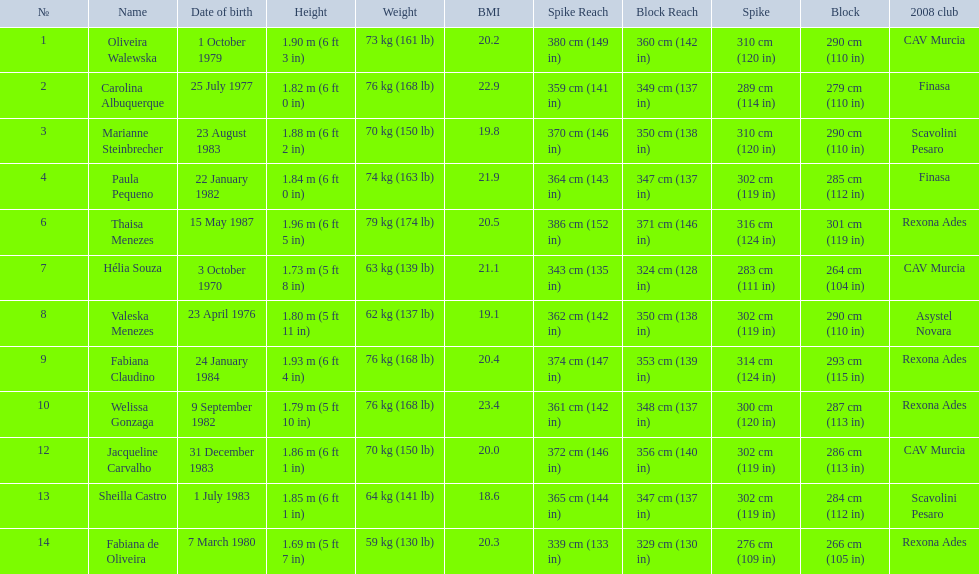What are all of the names? Oliveira Walewska, Carolina Albuquerque, Marianne Steinbrecher, Paula Pequeno, Thaisa Menezes, Hélia Souza, Valeska Menezes, Fabiana Claudino, Welissa Gonzaga, Jacqueline Carvalho, Sheilla Castro, Fabiana de Oliveira. What are their weights? 73 kg (161 lb), 76 kg (168 lb), 70 kg (150 lb), 74 kg (163 lb), 79 kg (174 lb), 63 kg (139 lb), 62 kg (137 lb), 76 kg (168 lb), 76 kg (168 lb), 70 kg (150 lb), 64 kg (141 lb), 59 kg (130 lb). How much did helia souza, fabiana de oliveira, and sheilla castro weigh? Hélia Souza, Sheilla Castro, Fabiana de Oliveira. And who weighed more? Sheilla Castro. 